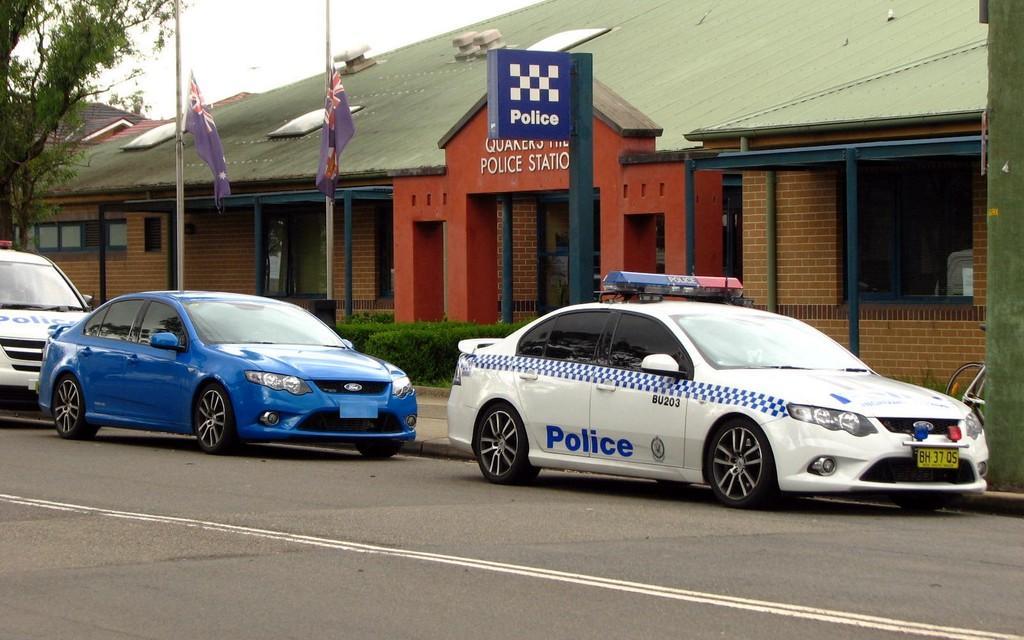Please provide a concise description of this image. In this image I can see three cars on the road. In the background I can see flag poles, trees, houses, windows, plants and the sky. This image is taken during a day on the road. 